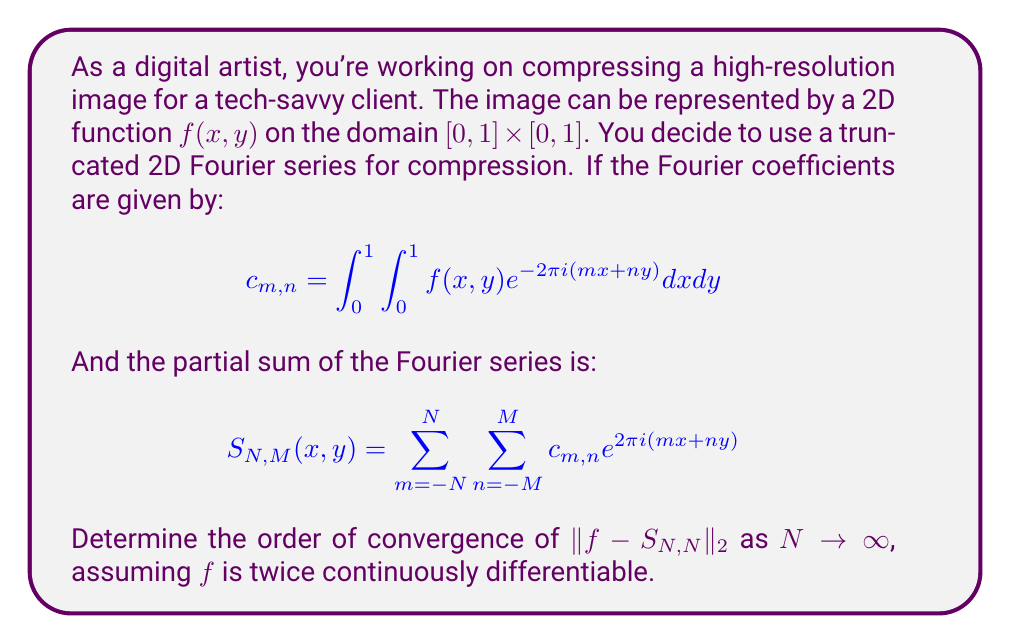Give your solution to this math problem. To analyze the convergence of the Fourier series for digital image compression, we need to consider the smoothness of the function $f(x,y)$ and use the properties of Fourier series.

1) First, recall that for a twice continuously differentiable function, the Fourier coefficients decay as:

   $|c_{m,n}| \leq \frac{C}{(m^2 + n^2)}$

   where $C$ is a constant depending on the function $f$.

2) The $L^2$ error can be expressed as:

   $\|f - S_{N,N}\|_2^2 = \int_0^1 \int_0^1 |f(x,y) - S_{N,N}(x,y)|^2 dx dy$

3) Using Parseval's identity, this is equivalent to:

   $\|f - S_{N,N}\|_2^2 = \sum_{|m|,|n| > N} |c_{m,n}|^2$

4) We can bound this sum:

   $\sum_{|m|,|n| > N} |c_{m,n}|^2 \leq C^2 \sum_{|m|,|n| > N} \frac{1}{(m^2 + n^2)^2}$

5) To estimate this sum, we can compare it to an integral:

   $\sum_{|m|,|n| > N} \frac{1}{(m^2 + n^2)^2} \approx \int_{r>N} \frac{1}{r^4} r dr d\theta$

   where we've switched to polar coordinates.

6) Evaluating this integral:

   $\int_{r>N} \frac{1}{r^4} r dr d\theta = 2\pi \int_N^\infty \frac{1}{r^3} dr = \frac{\pi}{N^2}$

7) Therefore, we can conclude that:

   $\|f - S_{N,N}\|_2^2 \leq \frac{C'}{N^2}$

   where $C'$ is a new constant.

8) Taking the square root of both sides:

   $\|f - S_{N,N}\|_2 \leq \frac{C''}{\sqrt{N^2}} = \frac{C''}{N}$

   where $C''$ is yet another constant.

This shows that the $L^2$ error of the truncated Fourier series converges to zero at a rate of $O(1/N)$ as $N \to \infty$.
Answer: The order of convergence of $\|f - S_{N,N}\|_2$ as $N \to \infty$ is $O(1/N)$. 